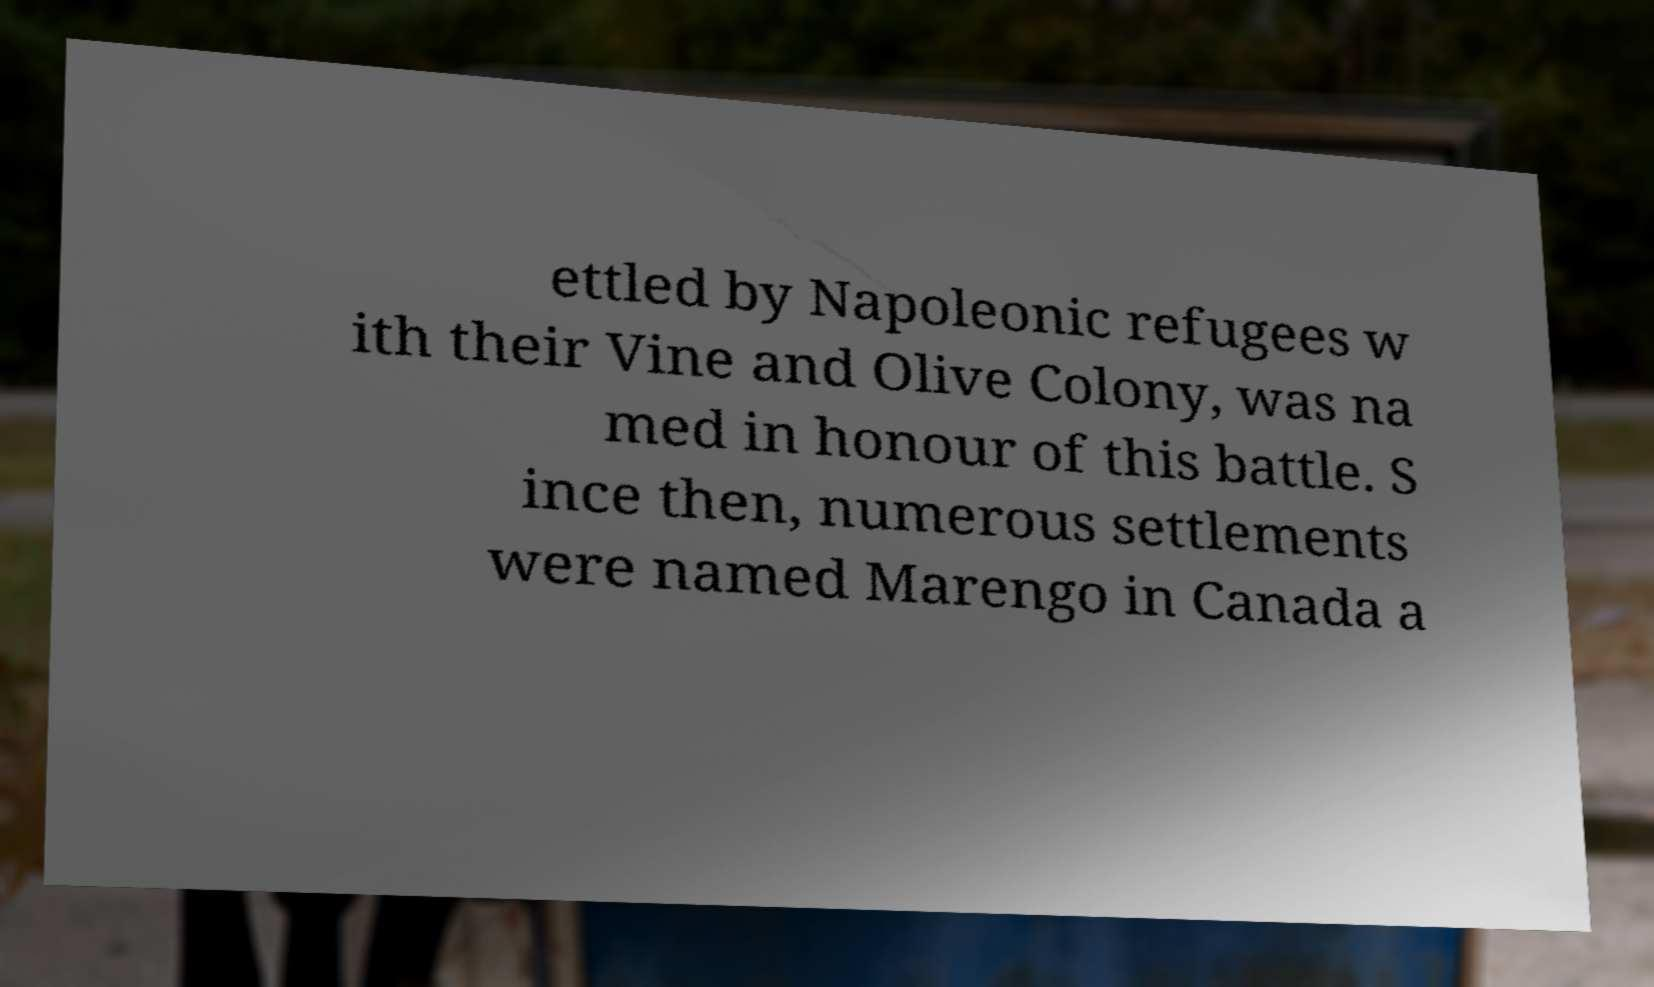There's text embedded in this image that I need extracted. Can you transcribe it verbatim? ettled by Napoleonic refugees w ith their Vine and Olive Colony, was na med in honour of this battle. S ince then, numerous settlements were named Marengo in Canada a 